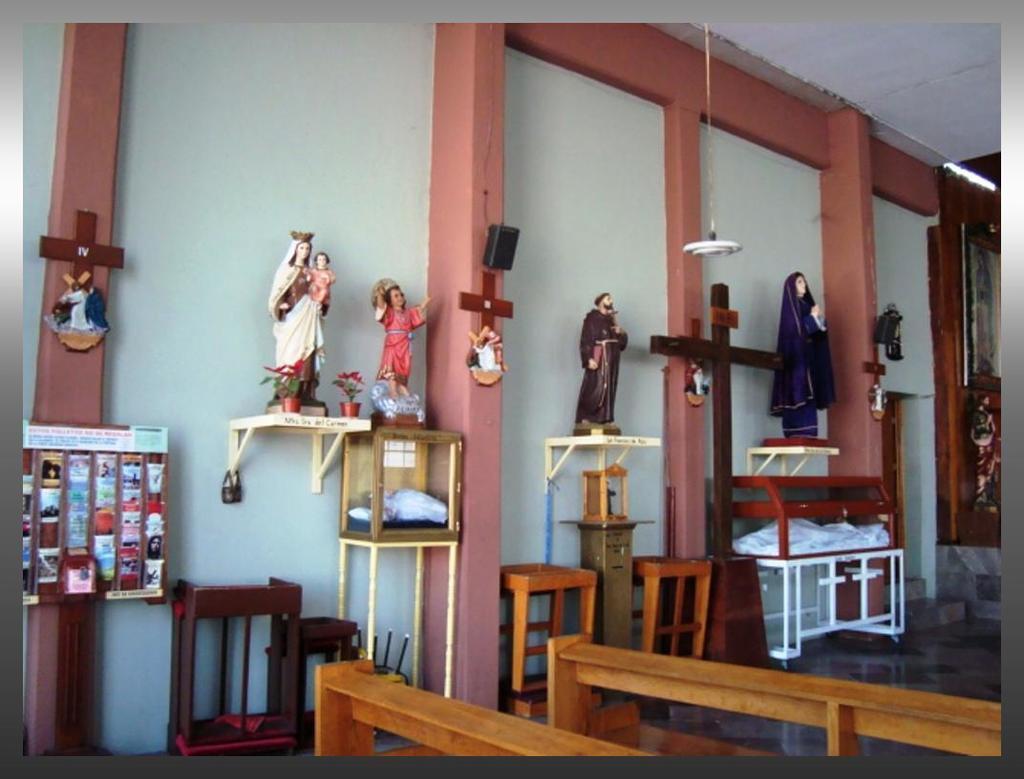Describe this image in one or two sentences. The picture might be taken in a church. In the foreground we can see benches. In the middle of the picture there are desks, sculpture, speaker, crosses and other objects. At the top it is ceiling. In the middle we can see pillars and wall as well. 